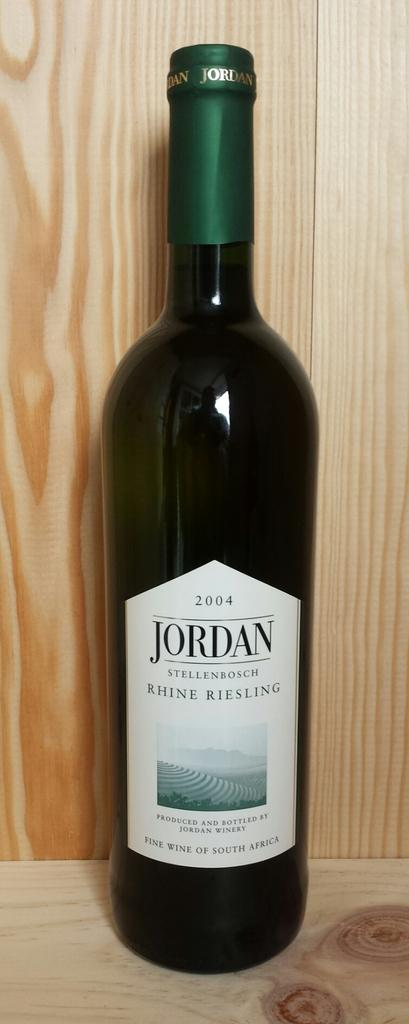<image>
Give a short and clear explanation of the subsequent image. Green bottle with a white label titled JORDAN from 2004. 